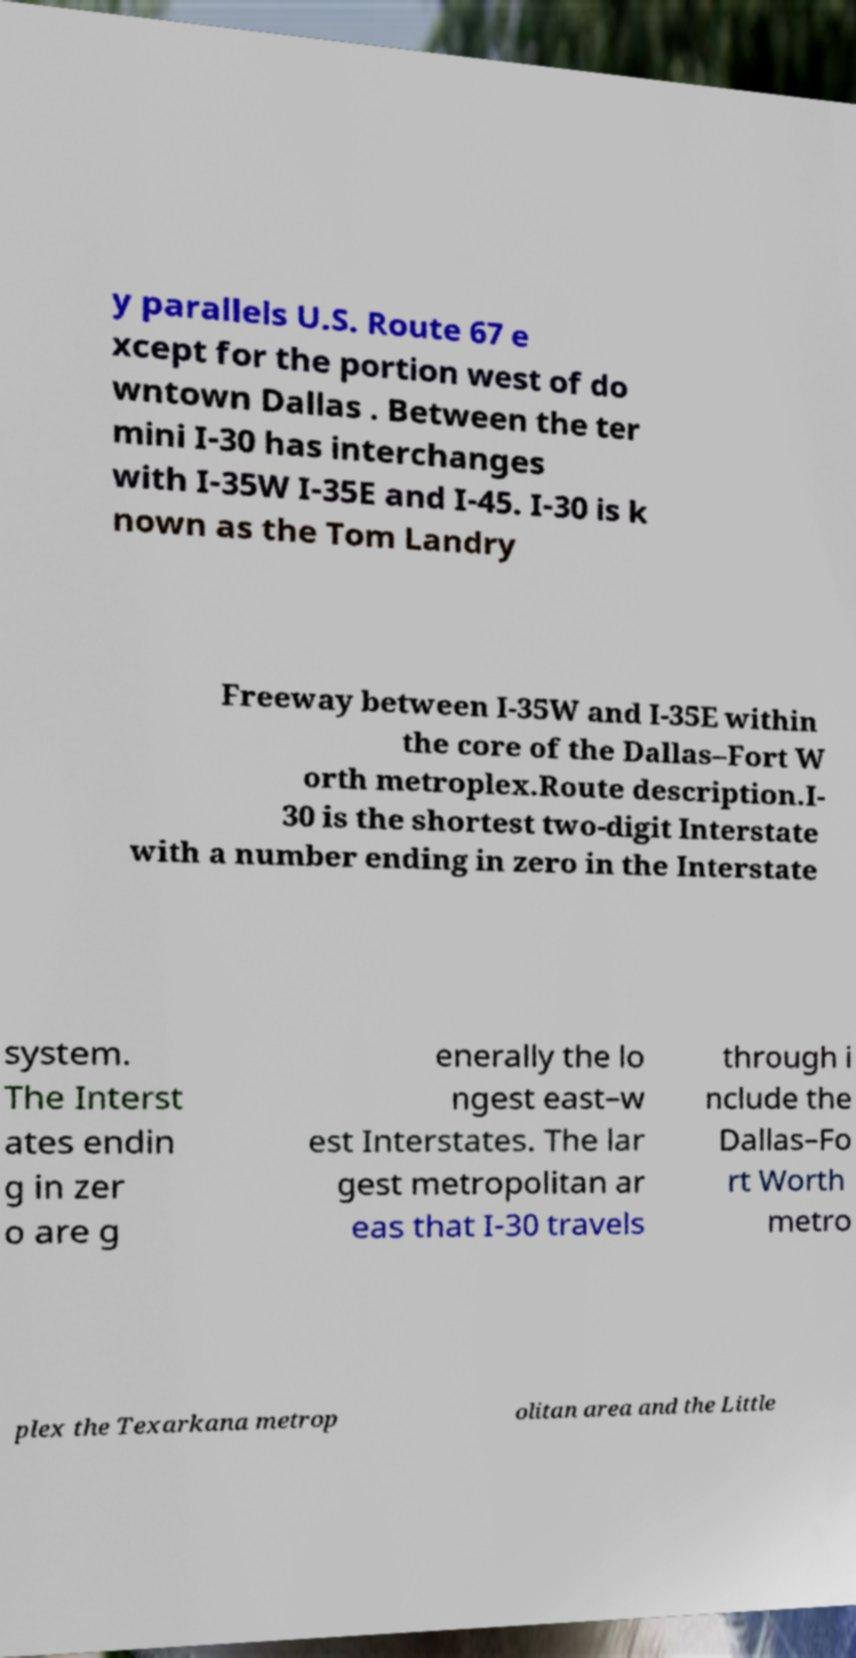I need the written content from this picture converted into text. Can you do that? y parallels U.S. Route 67 e xcept for the portion west of do wntown Dallas . Between the ter mini I-30 has interchanges with I-35W I-35E and I-45. I-30 is k nown as the Tom Landry Freeway between I-35W and I-35E within the core of the Dallas–Fort W orth metroplex.Route description.I- 30 is the shortest two-digit Interstate with a number ending in zero in the Interstate system. The Interst ates endin g in zer o are g enerally the lo ngest east–w est Interstates. The lar gest metropolitan ar eas that I-30 travels through i nclude the Dallas–Fo rt Worth metro plex the Texarkana metrop olitan area and the Little 